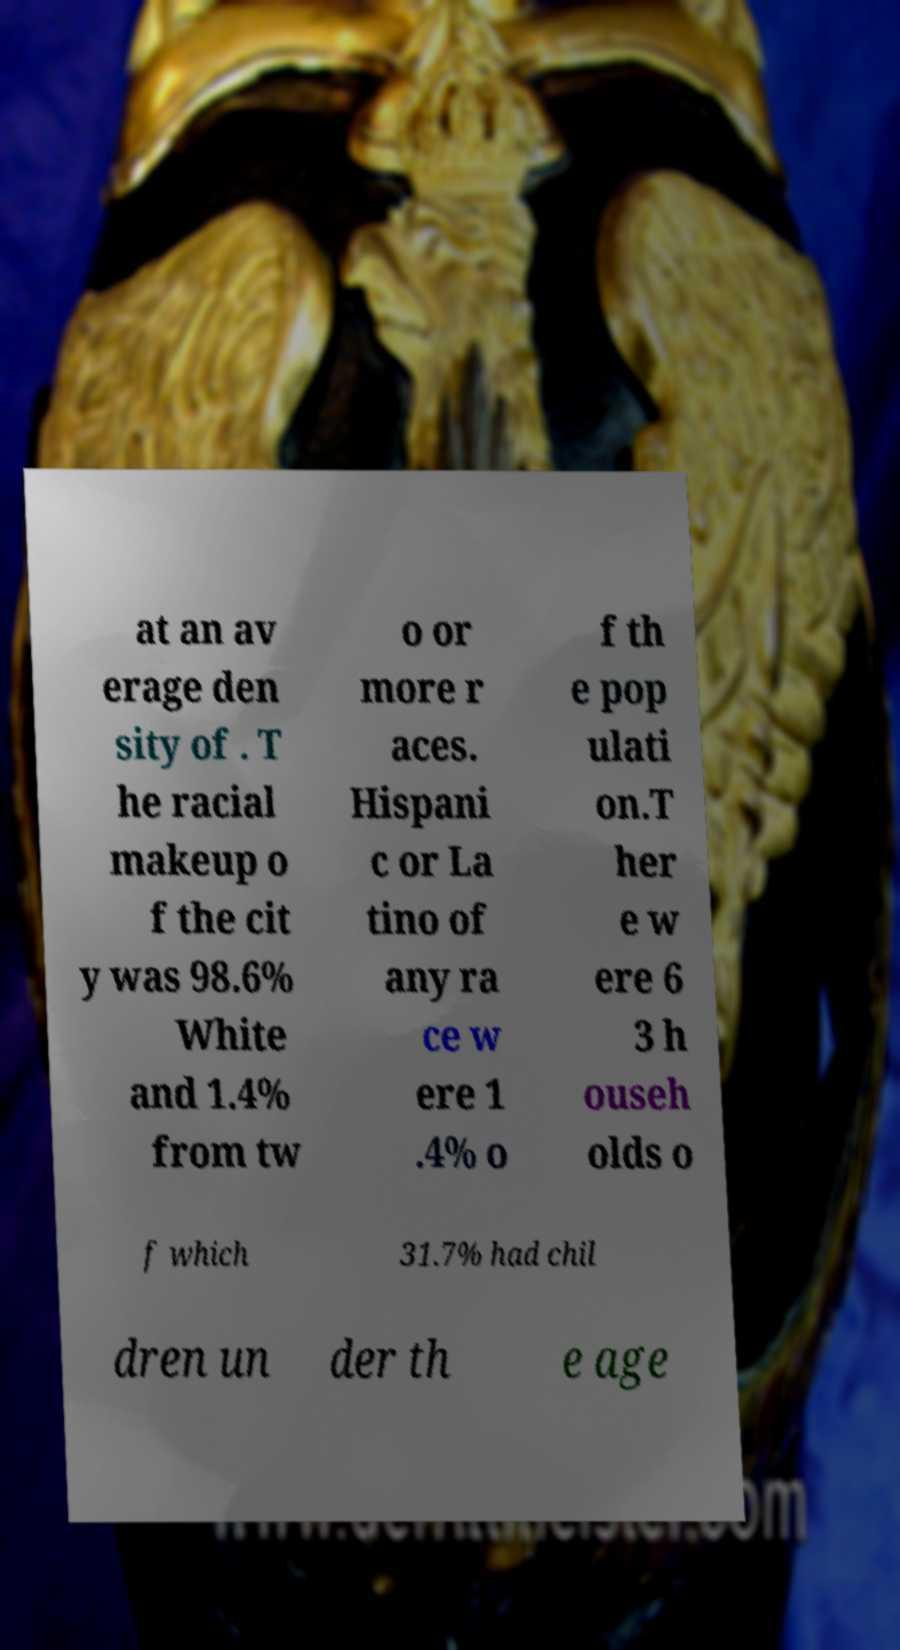Please identify and transcribe the text found in this image. at an av erage den sity of . T he racial makeup o f the cit y was 98.6% White and 1.4% from tw o or more r aces. Hispani c or La tino of any ra ce w ere 1 .4% o f th e pop ulati on.T her e w ere 6 3 h ouseh olds o f which 31.7% had chil dren un der th e age 